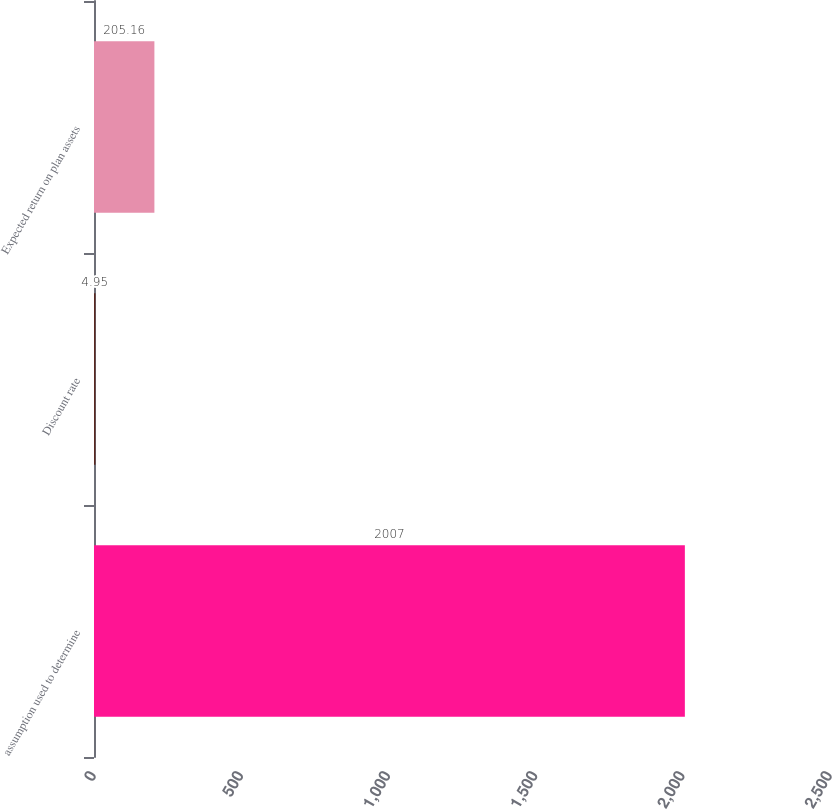Convert chart to OTSL. <chart><loc_0><loc_0><loc_500><loc_500><bar_chart><fcel>assumption used to determine<fcel>Discount rate<fcel>Expected return on plan assets<nl><fcel>2007<fcel>4.95<fcel>205.16<nl></chart> 